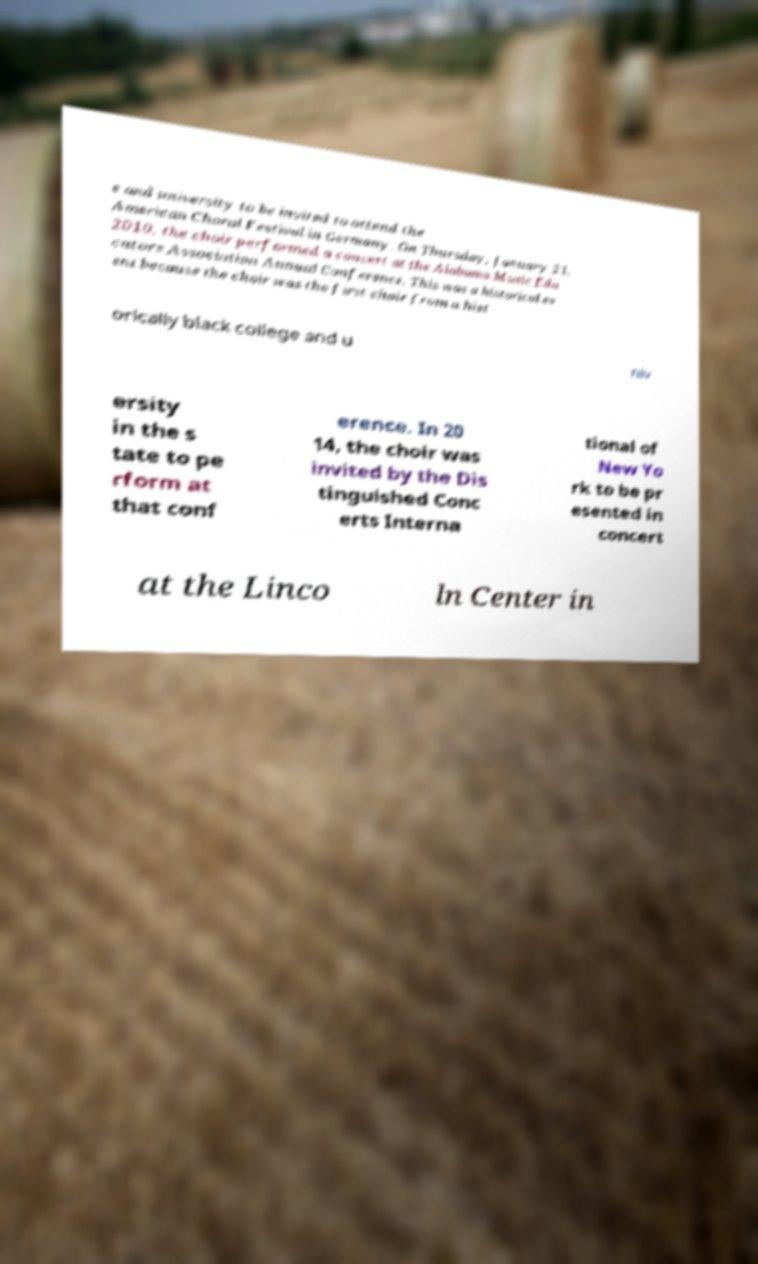Please identify and transcribe the text found in this image. e and university to be invited to attend the American Choral Festival in Germany. On Thursday, January 21, 2010, the choir performed a concert at the Alabama Music Edu cators Association Annual Conference. This was a historical ev ent because the choir was the first choir from a hist orically black college and u niv ersity in the s tate to pe rform at that conf erence. In 20 14, the choir was invited by the Dis tinguished Conc erts Interna tional of New Yo rk to be pr esented in concert at the Linco ln Center in 